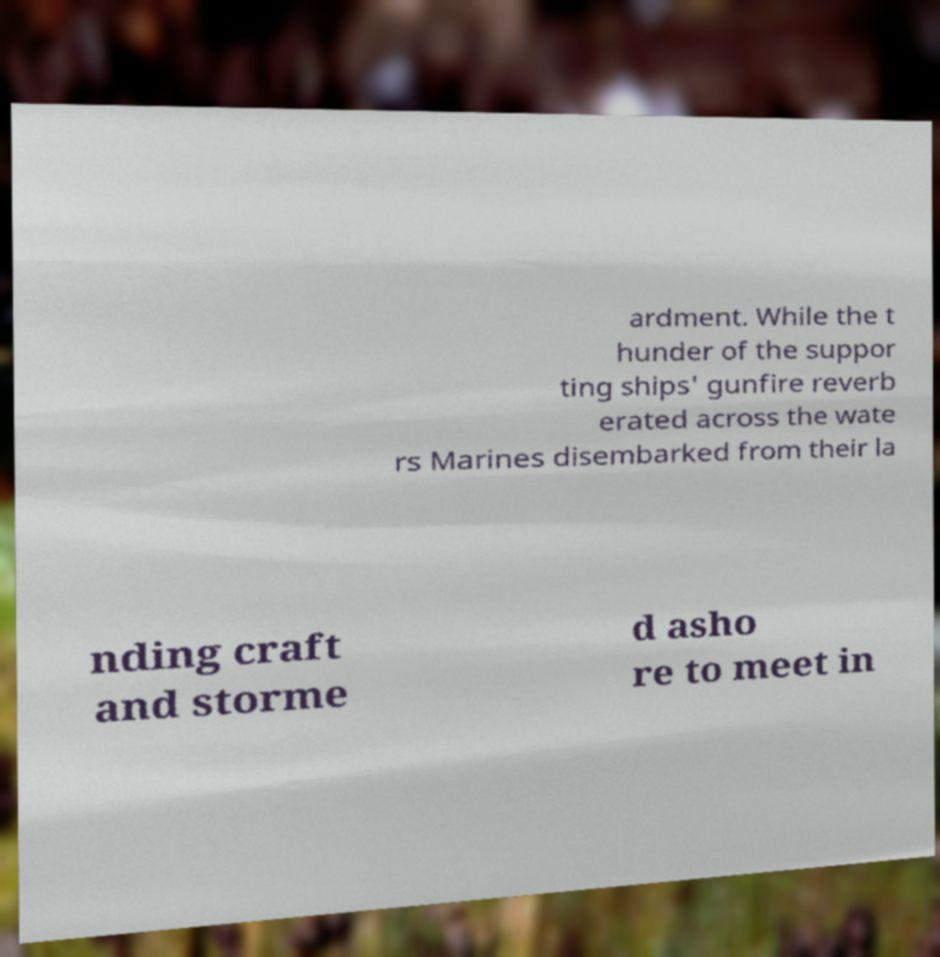For documentation purposes, I need the text within this image transcribed. Could you provide that? ardment. While the t hunder of the suppor ting ships' gunfire reverb erated across the wate rs Marines disembarked from their la nding craft and storme d asho re to meet in 